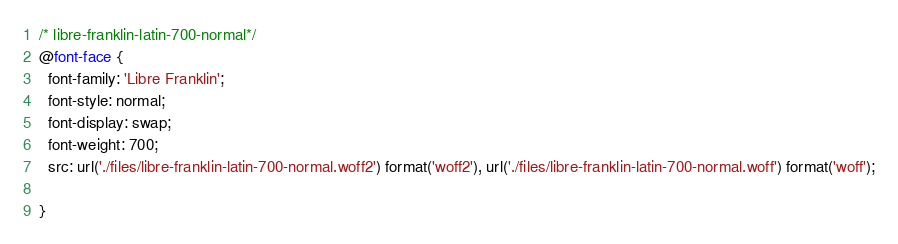Convert code to text. <code><loc_0><loc_0><loc_500><loc_500><_CSS_>/* libre-franklin-latin-700-normal*/
@font-face {
  font-family: 'Libre Franklin';
  font-style: normal;
  font-display: swap;
  font-weight: 700;
  src: url('./files/libre-franklin-latin-700-normal.woff2') format('woff2'), url('./files/libre-franklin-latin-700-normal.woff') format('woff');
  
}
</code> 